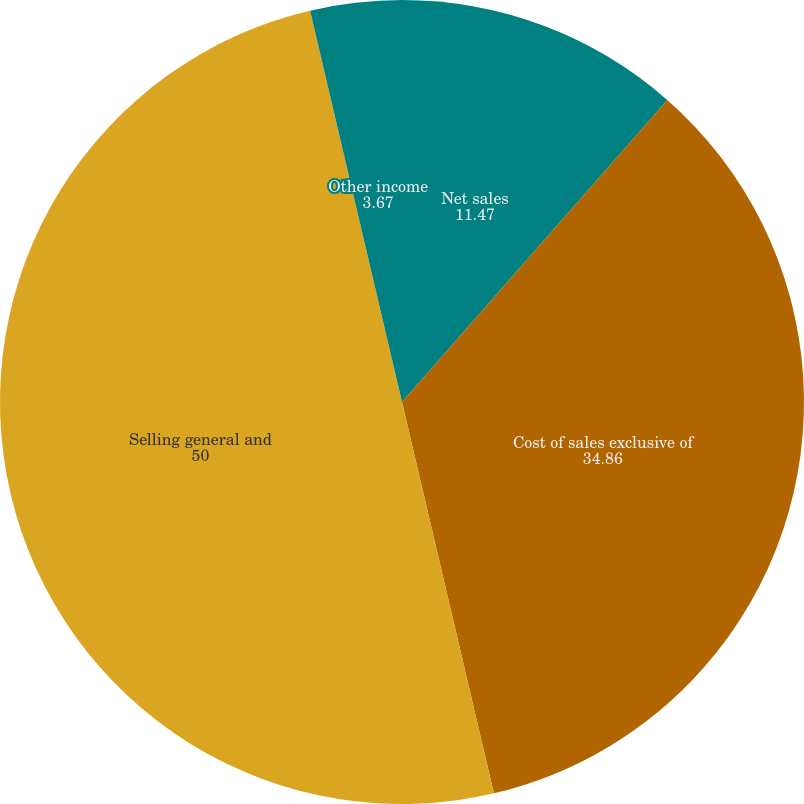Convert chart to OTSL. <chart><loc_0><loc_0><loc_500><loc_500><pie_chart><fcel>Net sales<fcel>Cost of sales exclusive of<fcel>Selling general and<fcel>Other income<nl><fcel>11.47%<fcel>34.86%<fcel>50.0%<fcel>3.67%<nl></chart> 